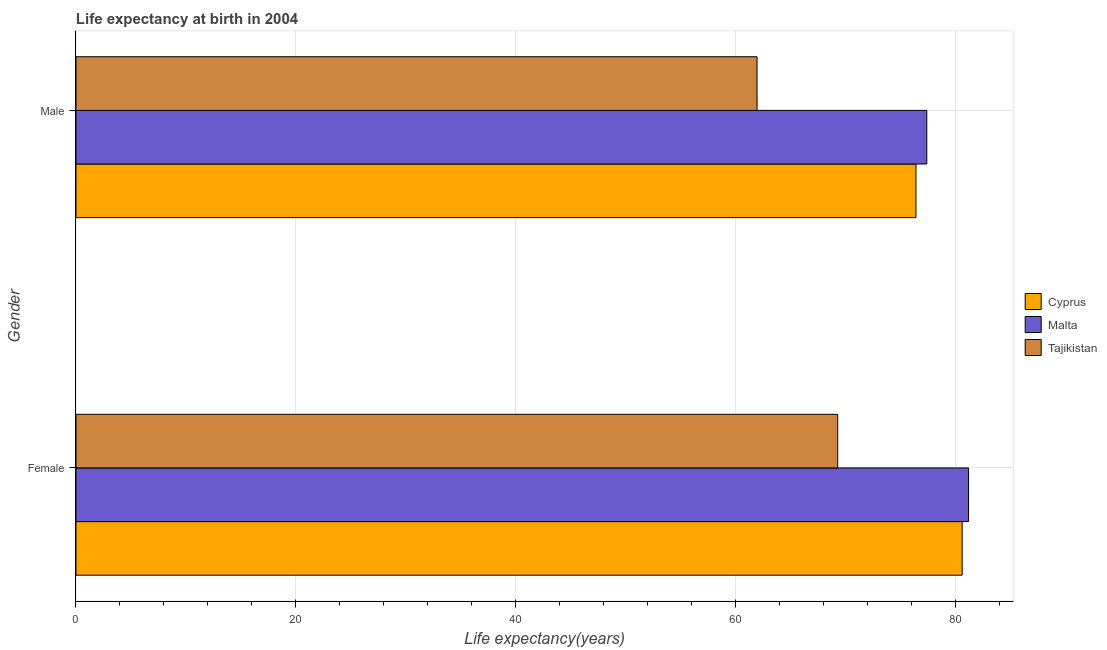How many groups of bars are there?
Give a very brief answer. 2. Are the number of bars per tick equal to the number of legend labels?
Provide a succinct answer. Yes. Are the number of bars on each tick of the Y-axis equal?
Offer a very short reply. Yes. How many bars are there on the 1st tick from the top?
Offer a terse response. 3. What is the label of the 1st group of bars from the top?
Give a very brief answer. Male. What is the life expectancy(male) in Cyprus?
Offer a terse response. 76.42. Across all countries, what is the maximum life expectancy(male)?
Your answer should be compact. 77.4. Across all countries, what is the minimum life expectancy(male)?
Your answer should be very brief. 61.96. In which country was the life expectancy(female) maximum?
Your response must be concise. Malta. In which country was the life expectancy(male) minimum?
Provide a succinct answer. Tajikistan. What is the total life expectancy(male) in the graph?
Offer a very short reply. 215.77. What is the difference between the life expectancy(female) in Malta and that in Cyprus?
Offer a very short reply. 0.58. What is the difference between the life expectancy(female) in Malta and the life expectancy(male) in Tajikistan?
Keep it short and to the point. 19.24. What is the average life expectancy(female) per country?
Ensure brevity in your answer.  77.04. What is the difference between the life expectancy(male) and life expectancy(female) in Malta?
Your response must be concise. -3.8. What is the ratio of the life expectancy(male) in Tajikistan to that in Cyprus?
Provide a succinct answer. 0.81. Is the life expectancy(male) in Tajikistan less than that in Cyprus?
Offer a very short reply. Yes. What does the 2nd bar from the top in Female represents?
Make the answer very short. Malta. What does the 1st bar from the bottom in Female represents?
Offer a terse response. Cyprus. How many countries are there in the graph?
Offer a very short reply. 3. What is the difference between two consecutive major ticks on the X-axis?
Keep it short and to the point. 20. Are the values on the major ticks of X-axis written in scientific E-notation?
Make the answer very short. No. Where does the legend appear in the graph?
Your answer should be very brief. Center right. How are the legend labels stacked?
Provide a succinct answer. Vertical. What is the title of the graph?
Give a very brief answer. Life expectancy at birth in 2004. What is the label or title of the X-axis?
Make the answer very short. Life expectancy(years). What is the Life expectancy(years) of Cyprus in Female?
Offer a terse response. 80.62. What is the Life expectancy(years) in Malta in Female?
Provide a succinct answer. 81.2. What is the Life expectancy(years) in Tajikistan in Female?
Keep it short and to the point. 69.3. What is the Life expectancy(years) in Cyprus in Male?
Make the answer very short. 76.42. What is the Life expectancy(years) in Malta in Male?
Offer a terse response. 77.4. What is the Life expectancy(years) in Tajikistan in Male?
Offer a terse response. 61.96. Across all Gender, what is the maximum Life expectancy(years) in Cyprus?
Your answer should be very brief. 80.62. Across all Gender, what is the maximum Life expectancy(years) in Malta?
Keep it short and to the point. 81.2. Across all Gender, what is the maximum Life expectancy(years) in Tajikistan?
Provide a short and direct response. 69.3. Across all Gender, what is the minimum Life expectancy(years) of Cyprus?
Keep it short and to the point. 76.42. Across all Gender, what is the minimum Life expectancy(years) of Malta?
Offer a very short reply. 77.4. Across all Gender, what is the minimum Life expectancy(years) in Tajikistan?
Keep it short and to the point. 61.96. What is the total Life expectancy(years) of Cyprus in the graph?
Your answer should be compact. 157.03. What is the total Life expectancy(years) of Malta in the graph?
Offer a very short reply. 158.6. What is the total Life expectancy(years) of Tajikistan in the graph?
Make the answer very short. 131.25. What is the difference between the Life expectancy(years) in Cyprus in Female and that in Male?
Ensure brevity in your answer.  4.2. What is the difference between the Life expectancy(years) of Tajikistan in Female and that in Male?
Keep it short and to the point. 7.34. What is the difference between the Life expectancy(years) in Cyprus in Female and the Life expectancy(years) in Malta in Male?
Provide a short and direct response. 3.22. What is the difference between the Life expectancy(years) in Cyprus in Female and the Life expectancy(years) in Tajikistan in Male?
Ensure brevity in your answer.  18.66. What is the difference between the Life expectancy(years) of Malta in Female and the Life expectancy(years) of Tajikistan in Male?
Offer a very short reply. 19.24. What is the average Life expectancy(years) in Cyprus per Gender?
Make the answer very short. 78.52. What is the average Life expectancy(years) in Malta per Gender?
Keep it short and to the point. 79.3. What is the average Life expectancy(years) in Tajikistan per Gender?
Your answer should be compact. 65.63. What is the difference between the Life expectancy(years) of Cyprus and Life expectancy(years) of Malta in Female?
Give a very brief answer. -0.58. What is the difference between the Life expectancy(years) in Cyprus and Life expectancy(years) in Tajikistan in Female?
Make the answer very short. 11.32. What is the difference between the Life expectancy(years) in Malta and Life expectancy(years) in Tajikistan in Female?
Your answer should be compact. 11.9. What is the difference between the Life expectancy(years) in Cyprus and Life expectancy(years) in Malta in Male?
Offer a terse response. -0.98. What is the difference between the Life expectancy(years) in Cyprus and Life expectancy(years) in Tajikistan in Male?
Ensure brevity in your answer.  14.46. What is the difference between the Life expectancy(years) of Malta and Life expectancy(years) of Tajikistan in Male?
Offer a terse response. 15.44. What is the ratio of the Life expectancy(years) of Cyprus in Female to that in Male?
Your answer should be very brief. 1.05. What is the ratio of the Life expectancy(years) of Malta in Female to that in Male?
Ensure brevity in your answer.  1.05. What is the ratio of the Life expectancy(years) in Tajikistan in Female to that in Male?
Provide a succinct answer. 1.12. What is the difference between the highest and the second highest Life expectancy(years) of Cyprus?
Offer a terse response. 4.2. What is the difference between the highest and the second highest Life expectancy(years) in Tajikistan?
Your answer should be very brief. 7.34. What is the difference between the highest and the lowest Life expectancy(years) of Cyprus?
Ensure brevity in your answer.  4.2. What is the difference between the highest and the lowest Life expectancy(years) in Malta?
Keep it short and to the point. 3.8. What is the difference between the highest and the lowest Life expectancy(years) of Tajikistan?
Provide a succinct answer. 7.34. 